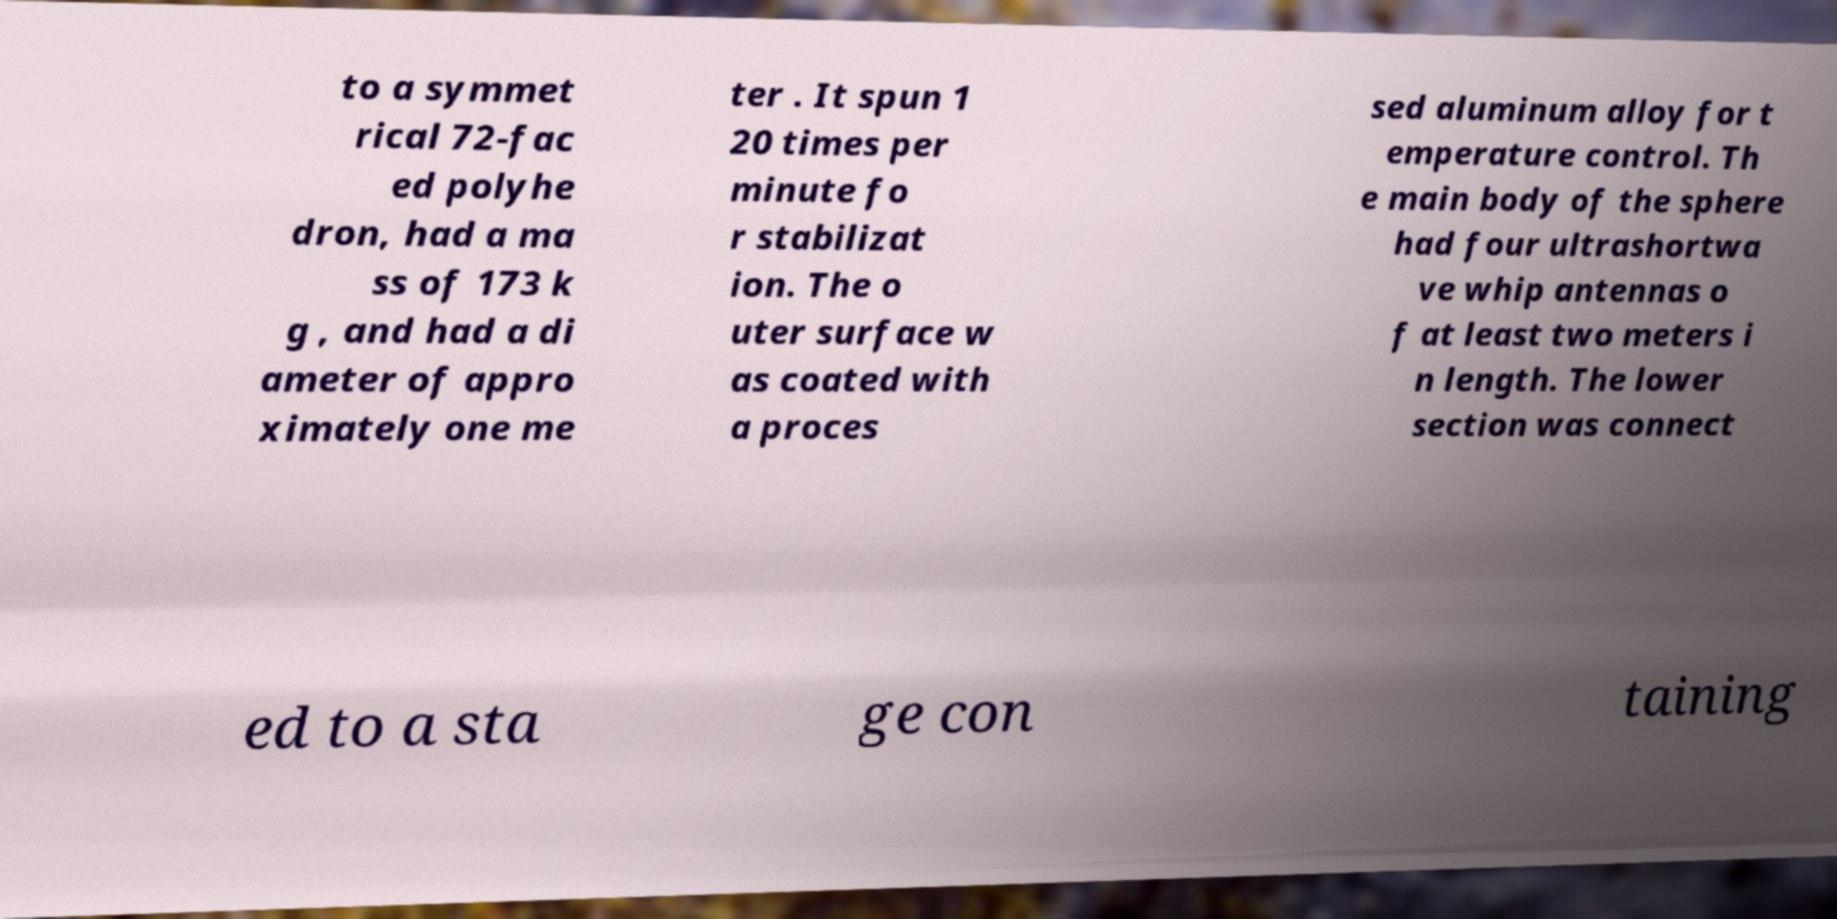What messages or text are displayed in this image? I need them in a readable, typed format. to a symmet rical 72-fac ed polyhe dron, had a ma ss of 173 k g , and had a di ameter of appro ximately one me ter . It spun 1 20 times per minute fo r stabilizat ion. The o uter surface w as coated with a proces sed aluminum alloy for t emperature control. Th e main body of the sphere had four ultrashortwa ve whip antennas o f at least two meters i n length. The lower section was connect ed to a sta ge con taining 